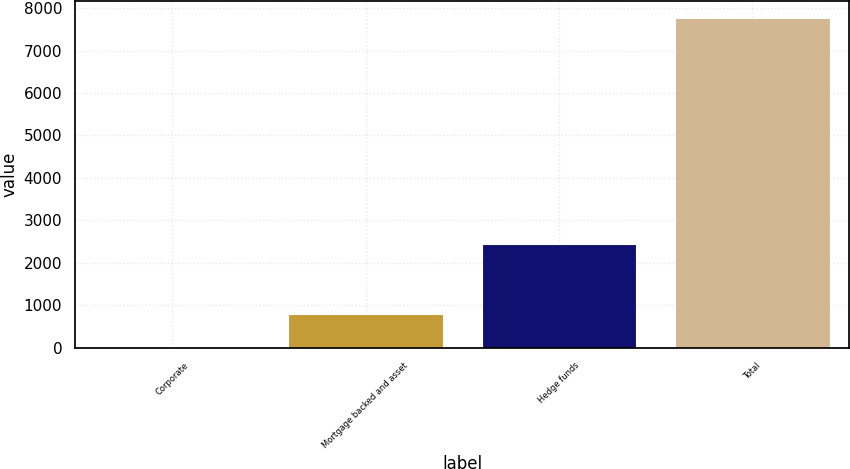<chart> <loc_0><loc_0><loc_500><loc_500><bar_chart><fcel>Corporate<fcel>Mortgage backed and asset<fcel>Hedge funds<fcel>Total<nl><fcel>11<fcel>787.6<fcel>2451<fcel>7777<nl></chart> 